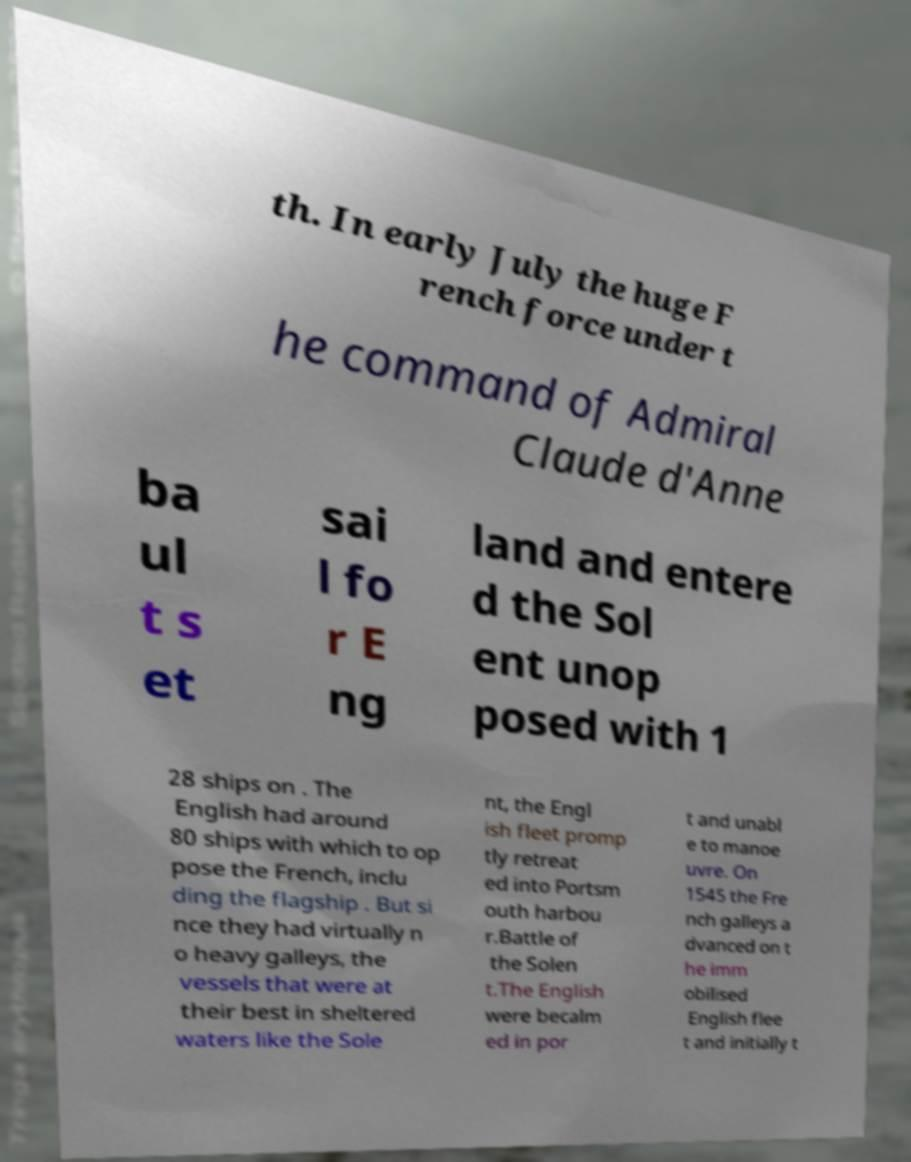There's text embedded in this image that I need extracted. Can you transcribe it verbatim? th. In early July the huge F rench force under t he command of Admiral Claude d'Anne ba ul t s et sai l fo r E ng land and entere d the Sol ent unop posed with 1 28 ships on . The English had around 80 ships with which to op pose the French, inclu ding the flagship . But si nce they had virtually n o heavy galleys, the vessels that were at their best in sheltered waters like the Sole nt, the Engl ish fleet promp tly retreat ed into Portsm outh harbou r.Battle of the Solen t.The English were becalm ed in por t and unabl e to manoe uvre. On 1545 the Fre nch galleys a dvanced on t he imm obilised English flee t and initially t 